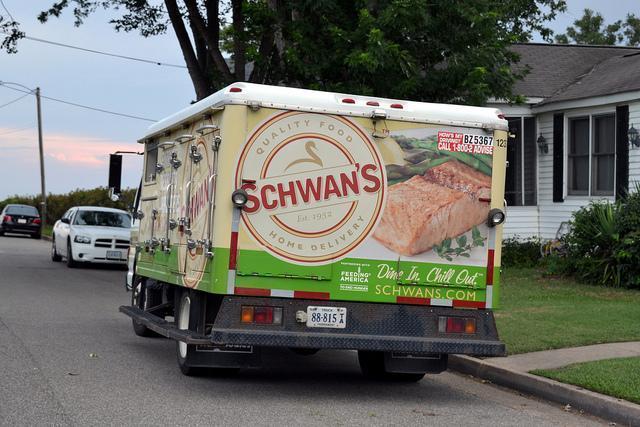How does the it feel inside the back of the truck?
Choose the right answer from the provided options to respond to the question.
Options: Muggy, warm, cold, scorching. Cold. 